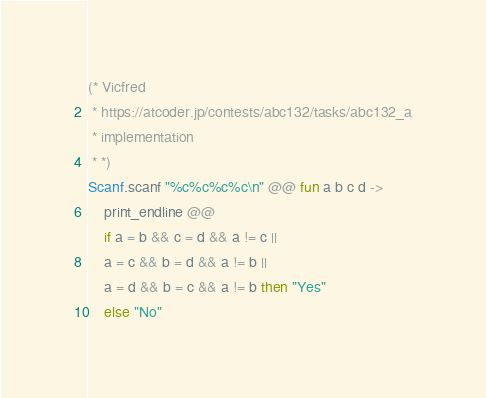Convert code to text. <code><loc_0><loc_0><loc_500><loc_500><_OCaml_>(* Vicfred
 * https://atcoder.jp/contests/abc132/tasks/abc132_a
 * implementation
 * *)
Scanf.scanf "%c%c%c%c\n" @@ fun a b c d ->
    print_endline @@
    if a = b && c = d && a != c ||
    a = c && b = d && a != b ||
    a = d && b = c && a != b then "Yes"
    else "No"

</code> 